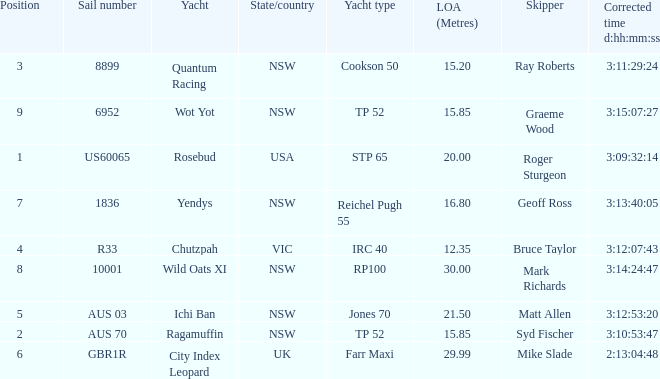What were all Yachts with a sail number of 6952? Wot Yot. 